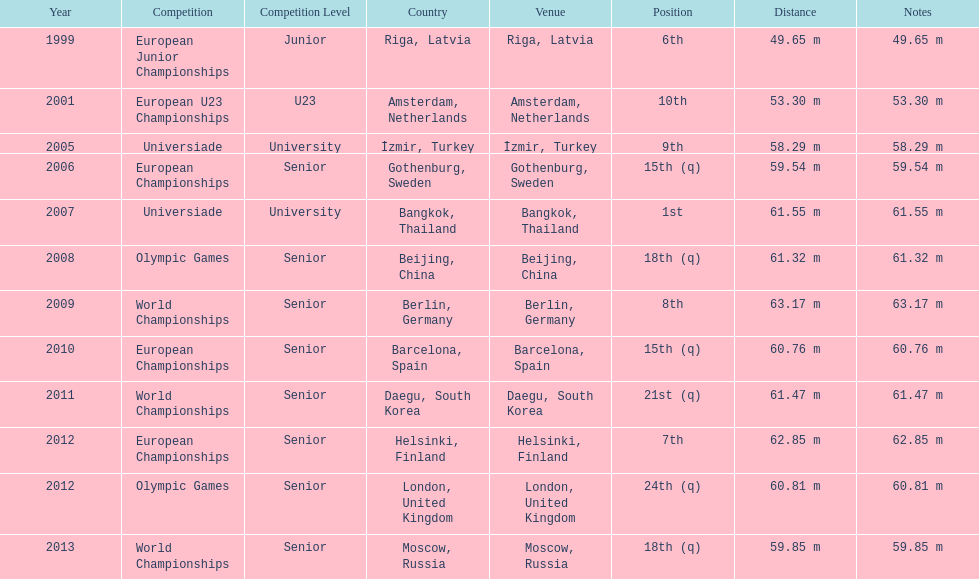How what listed year was a distance of only 53.30m reached? 2001. 